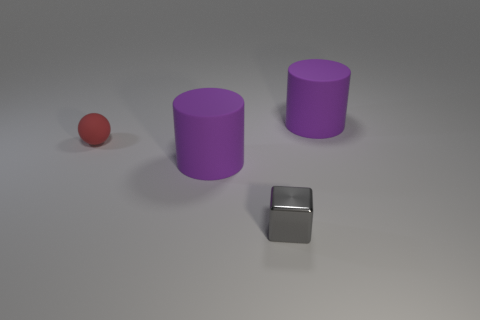Add 4 big purple objects. How many objects exist? 8 Subtract all cubes. How many objects are left? 3 Add 2 big matte cylinders. How many big matte cylinders exist? 4 Subtract 0 blue spheres. How many objects are left? 4 Subtract all cyan cylinders. Subtract all large purple matte things. How many objects are left? 2 Add 2 large purple cylinders. How many large purple cylinders are left? 4 